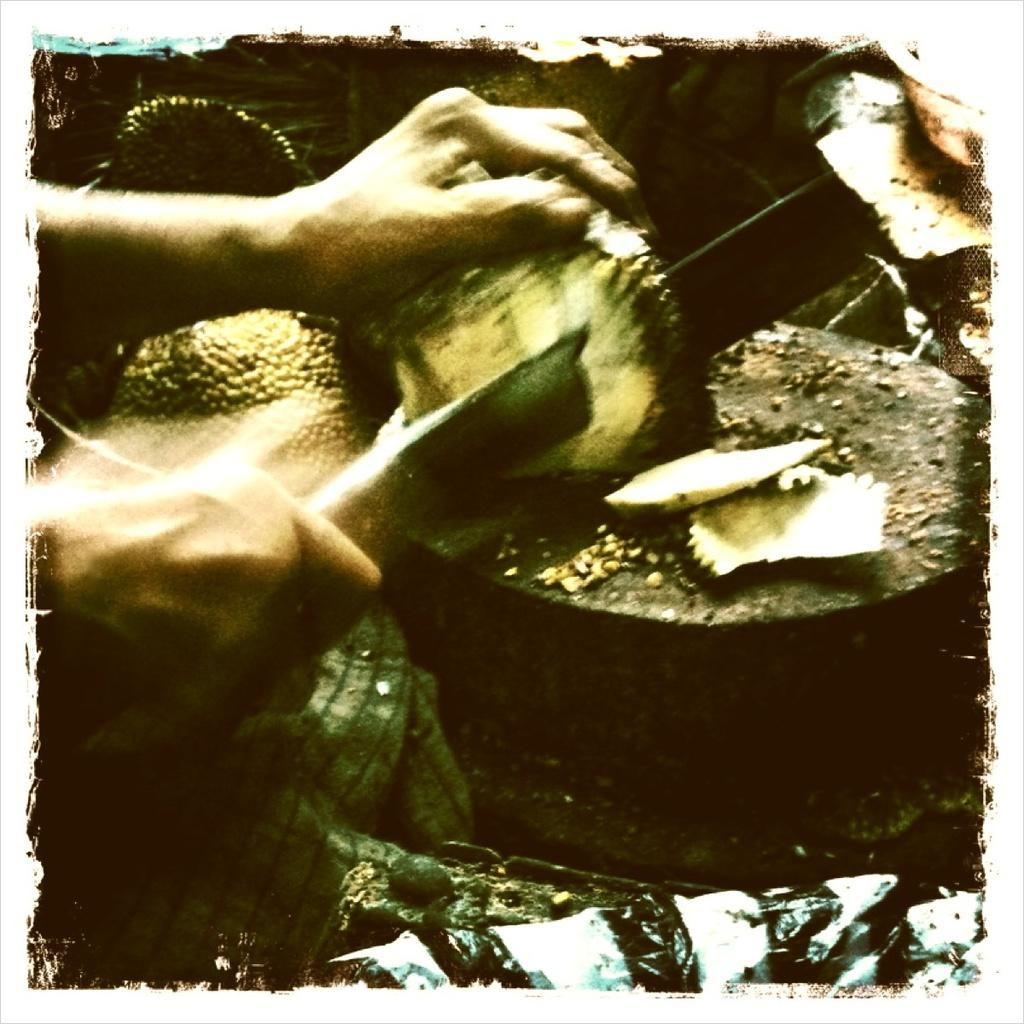Who is in the image? There is a person in the image. What is the person doing in the image? The person is cutting a fruit. What tool is the person using to cut the fruit? The person is using a knife. On what surface is the cutting taking place? The cutting is taking place on a wooden surface. How is the image displayed? The image appears to be in a photo frame. What grade does the person receive for their fruit cutting skills in the image? There is no indication of a grade or evaluation of the person's fruit cutting skills in the image. 